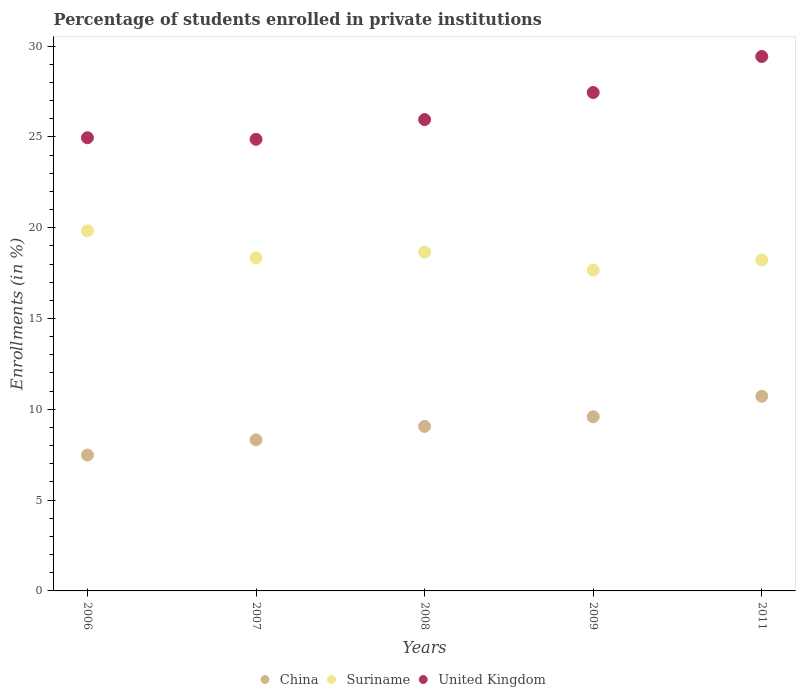How many different coloured dotlines are there?
Keep it short and to the point. 3. Is the number of dotlines equal to the number of legend labels?
Provide a short and direct response. Yes. What is the percentage of trained teachers in China in 2011?
Offer a terse response. 10.72. Across all years, what is the maximum percentage of trained teachers in Suriname?
Provide a short and direct response. 19.83. Across all years, what is the minimum percentage of trained teachers in United Kingdom?
Give a very brief answer. 24.87. In which year was the percentage of trained teachers in China maximum?
Offer a very short reply. 2011. In which year was the percentage of trained teachers in Suriname minimum?
Keep it short and to the point. 2009. What is the total percentage of trained teachers in Suriname in the graph?
Offer a terse response. 92.71. What is the difference between the percentage of trained teachers in Suriname in 2008 and that in 2011?
Give a very brief answer. 0.43. What is the difference between the percentage of trained teachers in Suriname in 2009 and the percentage of trained teachers in United Kingdom in 2007?
Your answer should be very brief. -7.2. What is the average percentage of trained teachers in Suriname per year?
Your answer should be compact. 18.54. In the year 2006, what is the difference between the percentage of trained teachers in China and percentage of trained teachers in Suriname?
Your answer should be compact. -12.35. In how many years, is the percentage of trained teachers in Suriname greater than 25 %?
Offer a very short reply. 0. What is the ratio of the percentage of trained teachers in Suriname in 2006 to that in 2007?
Make the answer very short. 1.08. Is the percentage of trained teachers in China in 2006 less than that in 2009?
Make the answer very short. Yes. What is the difference between the highest and the second highest percentage of trained teachers in Suriname?
Your answer should be very brief. 1.17. What is the difference between the highest and the lowest percentage of trained teachers in China?
Ensure brevity in your answer.  3.24. In how many years, is the percentage of trained teachers in China greater than the average percentage of trained teachers in China taken over all years?
Give a very brief answer. 3. Is the sum of the percentage of trained teachers in United Kingdom in 2008 and 2011 greater than the maximum percentage of trained teachers in Suriname across all years?
Make the answer very short. Yes. Is it the case that in every year, the sum of the percentage of trained teachers in China and percentage of trained teachers in Suriname  is greater than the percentage of trained teachers in United Kingdom?
Make the answer very short. No. Does the percentage of trained teachers in Suriname monotonically increase over the years?
Your answer should be compact. No. Is the percentage of trained teachers in Suriname strictly less than the percentage of trained teachers in United Kingdom over the years?
Provide a succinct answer. Yes. How many years are there in the graph?
Provide a short and direct response. 5. What is the difference between two consecutive major ticks on the Y-axis?
Ensure brevity in your answer.  5. Does the graph contain any zero values?
Offer a terse response. No. How many legend labels are there?
Your answer should be compact. 3. What is the title of the graph?
Your response must be concise. Percentage of students enrolled in private institutions. What is the label or title of the X-axis?
Your answer should be very brief. Years. What is the label or title of the Y-axis?
Ensure brevity in your answer.  Enrollments (in %). What is the Enrollments (in %) in China in 2006?
Make the answer very short. 7.48. What is the Enrollments (in %) of Suriname in 2006?
Provide a succinct answer. 19.83. What is the Enrollments (in %) in United Kingdom in 2006?
Provide a succinct answer. 24.95. What is the Enrollments (in %) in China in 2007?
Your answer should be compact. 8.32. What is the Enrollments (in %) of Suriname in 2007?
Provide a succinct answer. 18.34. What is the Enrollments (in %) in United Kingdom in 2007?
Offer a terse response. 24.87. What is the Enrollments (in %) in China in 2008?
Provide a succinct answer. 9.06. What is the Enrollments (in %) in Suriname in 2008?
Keep it short and to the point. 18.65. What is the Enrollments (in %) of United Kingdom in 2008?
Keep it short and to the point. 25.95. What is the Enrollments (in %) in China in 2009?
Give a very brief answer. 9.59. What is the Enrollments (in %) in Suriname in 2009?
Give a very brief answer. 17.67. What is the Enrollments (in %) in United Kingdom in 2009?
Make the answer very short. 27.44. What is the Enrollments (in %) of China in 2011?
Give a very brief answer. 10.72. What is the Enrollments (in %) of Suriname in 2011?
Give a very brief answer. 18.22. What is the Enrollments (in %) in United Kingdom in 2011?
Offer a very short reply. 29.43. Across all years, what is the maximum Enrollments (in %) in China?
Give a very brief answer. 10.72. Across all years, what is the maximum Enrollments (in %) in Suriname?
Your answer should be compact. 19.83. Across all years, what is the maximum Enrollments (in %) of United Kingdom?
Offer a terse response. 29.43. Across all years, what is the minimum Enrollments (in %) of China?
Your answer should be compact. 7.48. Across all years, what is the minimum Enrollments (in %) in Suriname?
Give a very brief answer. 17.67. Across all years, what is the minimum Enrollments (in %) of United Kingdom?
Keep it short and to the point. 24.87. What is the total Enrollments (in %) in China in the graph?
Your response must be concise. 45.17. What is the total Enrollments (in %) in Suriname in the graph?
Your answer should be very brief. 92.71. What is the total Enrollments (in %) of United Kingdom in the graph?
Offer a very short reply. 132.65. What is the difference between the Enrollments (in %) in China in 2006 and that in 2007?
Your response must be concise. -0.84. What is the difference between the Enrollments (in %) of Suriname in 2006 and that in 2007?
Your response must be concise. 1.49. What is the difference between the Enrollments (in %) in United Kingdom in 2006 and that in 2007?
Make the answer very short. 0.09. What is the difference between the Enrollments (in %) of China in 2006 and that in 2008?
Provide a succinct answer. -1.58. What is the difference between the Enrollments (in %) of Suriname in 2006 and that in 2008?
Your response must be concise. 1.17. What is the difference between the Enrollments (in %) of China in 2006 and that in 2009?
Make the answer very short. -2.11. What is the difference between the Enrollments (in %) of Suriname in 2006 and that in 2009?
Give a very brief answer. 2.16. What is the difference between the Enrollments (in %) of United Kingdom in 2006 and that in 2009?
Your response must be concise. -2.49. What is the difference between the Enrollments (in %) in China in 2006 and that in 2011?
Your answer should be compact. -3.24. What is the difference between the Enrollments (in %) of Suriname in 2006 and that in 2011?
Your answer should be compact. 1.6. What is the difference between the Enrollments (in %) of United Kingdom in 2006 and that in 2011?
Give a very brief answer. -4.47. What is the difference between the Enrollments (in %) in China in 2007 and that in 2008?
Your response must be concise. -0.74. What is the difference between the Enrollments (in %) of Suriname in 2007 and that in 2008?
Provide a succinct answer. -0.31. What is the difference between the Enrollments (in %) in United Kingdom in 2007 and that in 2008?
Offer a terse response. -1.09. What is the difference between the Enrollments (in %) in China in 2007 and that in 2009?
Offer a very short reply. -1.27. What is the difference between the Enrollments (in %) of Suriname in 2007 and that in 2009?
Give a very brief answer. 0.67. What is the difference between the Enrollments (in %) of United Kingdom in 2007 and that in 2009?
Your answer should be compact. -2.58. What is the difference between the Enrollments (in %) in China in 2007 and that in 2011?
Keep it short and to the point. -2.4. What is the difference between the Enrollments (in %) of Suriname in 2007 and that in 2011?
Your answer should be compact. 0.12. What is the difference between the Enrollments (in %) of United Kingdom in 2007 and that in 2011?
Your response must be concise. -4.56. What is the difference between the Enrollments (in %) of China in 2008 and that in 2009?
Ensure brevity in your answer.  -0.53. What is the difference between the Enrollments (in %) of Suriname in 2008 and that in 2009?
Make the answer very short. 0.99. What is the difference between the Enrollments (in %) of United Kingdom in 2008 and that in 2009?
Ensure brevity in your answer.  -1.49. What is the difference between the Enrollments (in %) in China in 2008 and that in 2011?
Provide a short and direct response. -1.66. What is the difference between the Enrollments (in %) in Suriname in 2008 and that in 2011?
Give a very brief answer. 0.43. What is the difference between the Enrollments (in %) in United Kingdom in 2008 and that in 2011?
Provide a succinct answer. -3.47. What is the difference between the Enrollments (in %) in China in 2009 and that in 2011?
Give a very brief answer. -1.13. What is the difference between the Enrollments (in %) in Suriname in 2009 and that in 2011?
Your answer should be compact. -0.56. What is the difference between the Enrollments (in %) in United Kingdom in 2009 and that in 2011?
Provide a short and direct response. -1.98. What is the difference between the Enrollments (in %) in China in 2006 and the Enrollments (in %) in Suriname in 2007?
Offer a very short reply. -10.86. What is the difference between the Enrollments (in %) in China in 2006 and the Enrollments (in %) in United Kingdom in 2007?
Ensure brevity in your answer.  -17.39. What is the difference between the Enrollments (in %) of Suriname in 2006 and the Enrollments (in %) of United Kingdom in 2007?
Provide a short and direct response. -5.04. What is the difference between the Enrollments (in %) in China in 2006 and the Enrollments (in %) in Suriname in 2008?
Ensure brevity in your answer.  -11.17. What is the difference between the Enrollments (in %) of China in 2006 and the Enrollments (in %) of United Kingdom in 2008?
Ensure brevity in your answer.  -18.47. What is the difference between the Enrollments (in %) of Suriname in 2006 and the Enrollments (in %) of United Kingdom in 2008?
Ensure brevity in your answer.  -6.13. What is the difference between the Enrollments (in %) of China in 2006 and the Enrollments (in %) of Suriname in 2009?
Your response must be concise. -10.19. What is the difference between the Enrollments (in %) of China in 2006 and the Enrollments (in %) of United Kingdom in 2009?
Your answer should be very brief. -19.96. What is the difference between the Enrollments (in %) of Suriname in 2006 and the Enrollments (in %) of United Kingdom in 2009?
Offer a very short reply. -7.62. What is the difference between the Enrollments (in %) of China in 2006 and the Enrollments (in %) of Suriname in 2011?
Your answer should be compact. -10.74. What is the difference between the Enrollments (in %) of China in 2006 and the Enrollments (in %) of United Kingdom in 2011?
Ensure brevity in your answer.  -21.95. What is the difference between the Enrollments (in %) of Suriname in 2006 and the Enrollments (in %) of United Kingdom in 2011?
Provide a succinct answer. -9.6. What is the difference between the Enrollments (in %) in China in 2007 and the Enrollments (in %) in Suriname in 2008?
Ensure brevity in your answer.  -10.33. What is the difference between the Enrollments (in %) in China in 2007 and the Enrollments (in %) in United Kingdom in 2008?
Give a very brief answer. -17.63. What is the difference between the Enrollments (in %) in Suriname in 2007 and the Enrollments (in %) in United Kingdom in 2008?
Offer a very short reply. -7.61. What is the difference between the Enrollments (in %) in China in 2007 and the Enrollments (in %) in Suriname in 2009?
Provide a succinct answer. -9.34. What is the difference between the Enrollments (in %) of China in 2007 and the Enrollments (in %) of United Kingdom in 2009?
Offer a very short reply. -19.12. What is the difference between the Enrollments (in %) in Suriname in 2007 and the Enrollments (in %) in United Kingdom in 2009?
Your response must be concise. -9.1. What is the difference between the Enrollments (in %) of China in 2007 and the Enrollments (in %) of Suriname in 2011?
Your answer should be compact. -9.9. What is the difference between the Enrollments (in %) in China in 2007 and the Enrollments (in %) in United Kingdom in 2011?
Provide a short and direct response. -21.11. What is the difference between the Enrollments (in %) in Suriname in 2007 and the Enrollments (in %) in United Kingdom in 2011?
Ensure brevity in your answer.  -11.09. What is the difference between the Enrollments (in %) in China in 2008 and the Enrollments (in %) in Suriname in 2009?
Your answer should be compact. -8.61. What is the difference between the Enrollments (in %) in China in 2008 and the Enrollments (in %) in United Kingdom in 2009?
Your response must be concise. -18.39. What is the difference between the Enrollments (in %) in Suriname in 2008 and the Enrollments (in %) in United Kingdom in 2009?
Your answer should be very brief. -8.79. What is the difference between the Enrollments (in %) of China in 2008 and the Enrollments (in %) of Suriname in 2011?
Ensure brevity in your answer.  -9.17. What is the difference between the Enrollments (in %) of China in 2008 and the Enrollments (in %) of United Kingdom in 2011?
Provide a short and direct response. -20.37. What is the difference between the Enrollments (in %) in Suriname in 2008 and the Enrollments (in %) in United Kingdom in 2011?
Make the answer very short. -10.77. What is the difference between the Enrollments (in %) of China in 2009 and the Enrollments (in %) of Suriname in 2011?
Provide a succinct answer. -8.63. What is the difference between the Enrollments (in %) in China in 2009 and the Enrollments (in %) in United Kingdom in 2011?
Provide a short and direct response. -19.84. What is the difference between the Enrollments (in %) in Suriname in 2009 and the Enrollments (in %) in United Kingdom in 2011?
Offer a very short reply. -11.76. What is the average Enrollments (in %) of China per year?
Your answer should be very brief. 9.03. What is the average Enrollments (in %) of Suriname per year?
Offer a very short reply. 18.54. What is the average Enrollments (in %) of United Kingdom per year?
Ensure brevity in your answer.  26.53. In the year 2006, what is the difference between the Enrollments (in %) in China and Enrollments (in %) in Suriname?
Your answer should be very brief. -12.35. In the year 2006, what is the difference between the Enrollments (in %) in China and Enrollments (in %) in United Kingdom?
Offer a very short reply. -17.47. In the year 2006, what is the difference between the Enrollments (in %) of Suriname and Enrollments (in %) of United Kingdom?
Keep it short and to the point. -5.13. In the year 2007, what is the difference between the Enrollments (in %) in China and Enrollments (in %) in Suriname?
Your answer should be very brief. -10.02. In the year 2007, what is the difference between the Enrollments (in %) of China and Enrollments (in %) of United Kingdom?
Offer a terse response. -16.55. In the year 2007, what is the difference between the Enrollments (in %) of Suriname and Enrollments (in %) of United Kingdom?
Ensure brevity in your answer.  -6.53. In the year 2008, what is the difference between the Enrollments (in %) of China and Enrollments (in %) of Suriname?
Make the answer very short. -9.6. In the year 2008, what is the difference between the Enrollments (in %) of China and Enrollments (in %) of United Kingdom?
Ensure brevity in your answer.  -16.9. In the year 2008, what is the difference between the Enrollments (in %) of Suriname and Enrollments (in %) of United Kingdom?
Keep it short and to the point. -7.3. In the year 2009, what is the difference between the Enrollments (in %) in China and Enrollments (in %) in Suriname?
Give a very brief answer. -8.07. In the year 2009, what is the difference between the Enrollments (in %) of China and Enrollments (in %) of United Kingdom?
Your response must be concise. -17.85. In the year 2009, what is the difference between the Enrollments (in %) of Suriname and Enrollments (in %) of United Kingdom?
Provide a short and direct response. -9.78. In the year 2011, what is the difference between the Enrollments (in %) of China and Enrollments (in %) of Suriname?
Your response must be concise. -7.51. In the year 2011, what is the difference between the Enrollments (in %) in China and Enrollments (in %) in United Kingdom?
Keep it short and to the point. -18.71. In the year 2011, what is the difference between the Enrollments (in %) in Suriname and Enrollments (in %) in United Kingdom?
Your response must be concise. -11.2. What is the ratio of the Enrollments (in %) of China in 2006 to that in 2007?
Provide a succinct answer. 0.9. What is the ratio of the Enrollments (in %) in Suriname in 2006 to that in 2007?
Give a very brief answer. 1.08. What is the ratio of the Enrollments (in %) in China in 2006 to that in 2008?
Offer a terse response. 0.83. What is the ratio of the Enrollments (in %) in Suriname in 2006 to that in 2008?
Ensure brevity in your answer.  1.06. What is the ratio of the Enrollments (in %) of United Kingdom in 2006 to that in 2008?
Provide a succinct answer. 0.96. What is the ratio of the Enrollments (in %) in China in 2006 to that in 2009?
Offer a terse response. 0.78. What is the ratio of the Enrollments (in %) of Suriname in 2006 to that in 2009?
Offer a terse response. 1.12. What is the ratio of the Enrollments (in %) of United Kingdom in 2006 to that in 2009?
Your answer should be compact. 0.91. What is the ratio of the Enrollments (in %) of China in 2006 to that in 2011?
Offer a terse response. 0.7. What is the ratio of the Enrollments (in %) of Suriname in 2006 to that in 2011?
Your response must be concise. 1.09. What is the ratio of the Enrollments (in %) of United Kingdom in 2006 to that in 2011?
Your response must be concise. 0.85. What is the ratio of the Enrollments (in %) of China in 2007 to that in 2008?
Provide a succinct answer. 0.92. What is the ratio of the Enrollments (in %) in Suriname in 2007 to that in 2008?
Provide a succinct answer. 0.98. What is the ratio of the Enrollments (in %) of United Kingdom in 2007 to that in 2008?
Your answer should be compact. 0.96. What is the ratio of the Enrollments (in %) of China in 2007 to that in 2009?
Offer a terse response. 0.87. What is the ratio of the Enrollments (in %) of Suriname in 2007 to that in 2009?
Give a very brief answer. 1.04. What is the ratio of the Enrollments (in %) of United Kingdom in 2007 to that in 2009?
Provide a succinct answer. 0.91. What is the ratio of the Enrollments (in %) of China in 2007 to that in 2011?
Give a very brief answer. 0.78. What is the ratio of the Enrollments (in %) of Suriname in 2007 to that in 2011?
Offer a very short reply. 1.01. What is the ratio of the Enrollments (in %) in United Kingdom in 2007 to that in 2011?
Provide a succinct answer. 0.85. What is the ratio of the Enrollments (in %) of China in 2008 to that in 2009?
Your response must be concise. 0.94. What is the ratio of the Enrollments (in %) in Suriname in 2008 to that in 2009?
Your answer should be compact. 1.06. What is the ratio of the Enrollments (in %) of United Kingdom in 2008 to that in 2009?
Keep it short and to the point. 0.95. What is the ratio of the Enrollments (in %) of China in 2008 to that in 2011?
Your answer should be compact. 0.85. What is the ratio of the Enrollments (in %) in Suriname in 2008 to that in 2011?
Offer a terse response. 1.02. What is the ratio of the Enrollments (in %) in United Kingdom in 2008 to that in 2011?
Make the answer very short. 0.88. What is the ratio of the Enrollments (in %) in China in 2009 to that in 2011?
Keep it short and to the point. 0.89. What is the ratio of the Enrollments (in %) of Suriname in 2009 to that in 2011?
Your answer should be compact. 0.97. What is the ratio of the Enrollments (in %) in United Kingdom in 2009 to that in 2011?
Offer a terse response. 0.93. What is the difference between the highest and the second highest Enrollments (in %) in China?
Offer a terse response. 1.13. What is the difference between the highest and the second highest Enrollments (in %) of Suriname?
Offer a very short reply. 1.17. What is the difference between the highest and the second highest Enrollments (in %) of United Kingdom?
Give a very brief answer. 1.98. What is the difference between the highest and the lowest Enrollments (in %) in China?
Provide a short and direct response. 3.24. What is the difference between the highest and the lowest Enrollments (in %) in Suriname?
Your answer should be compact. 2.16. What is the difference between the highest and the lowest Enrollments (in %) in United Kingdom?
Provide a succinct answer. 4.56. 